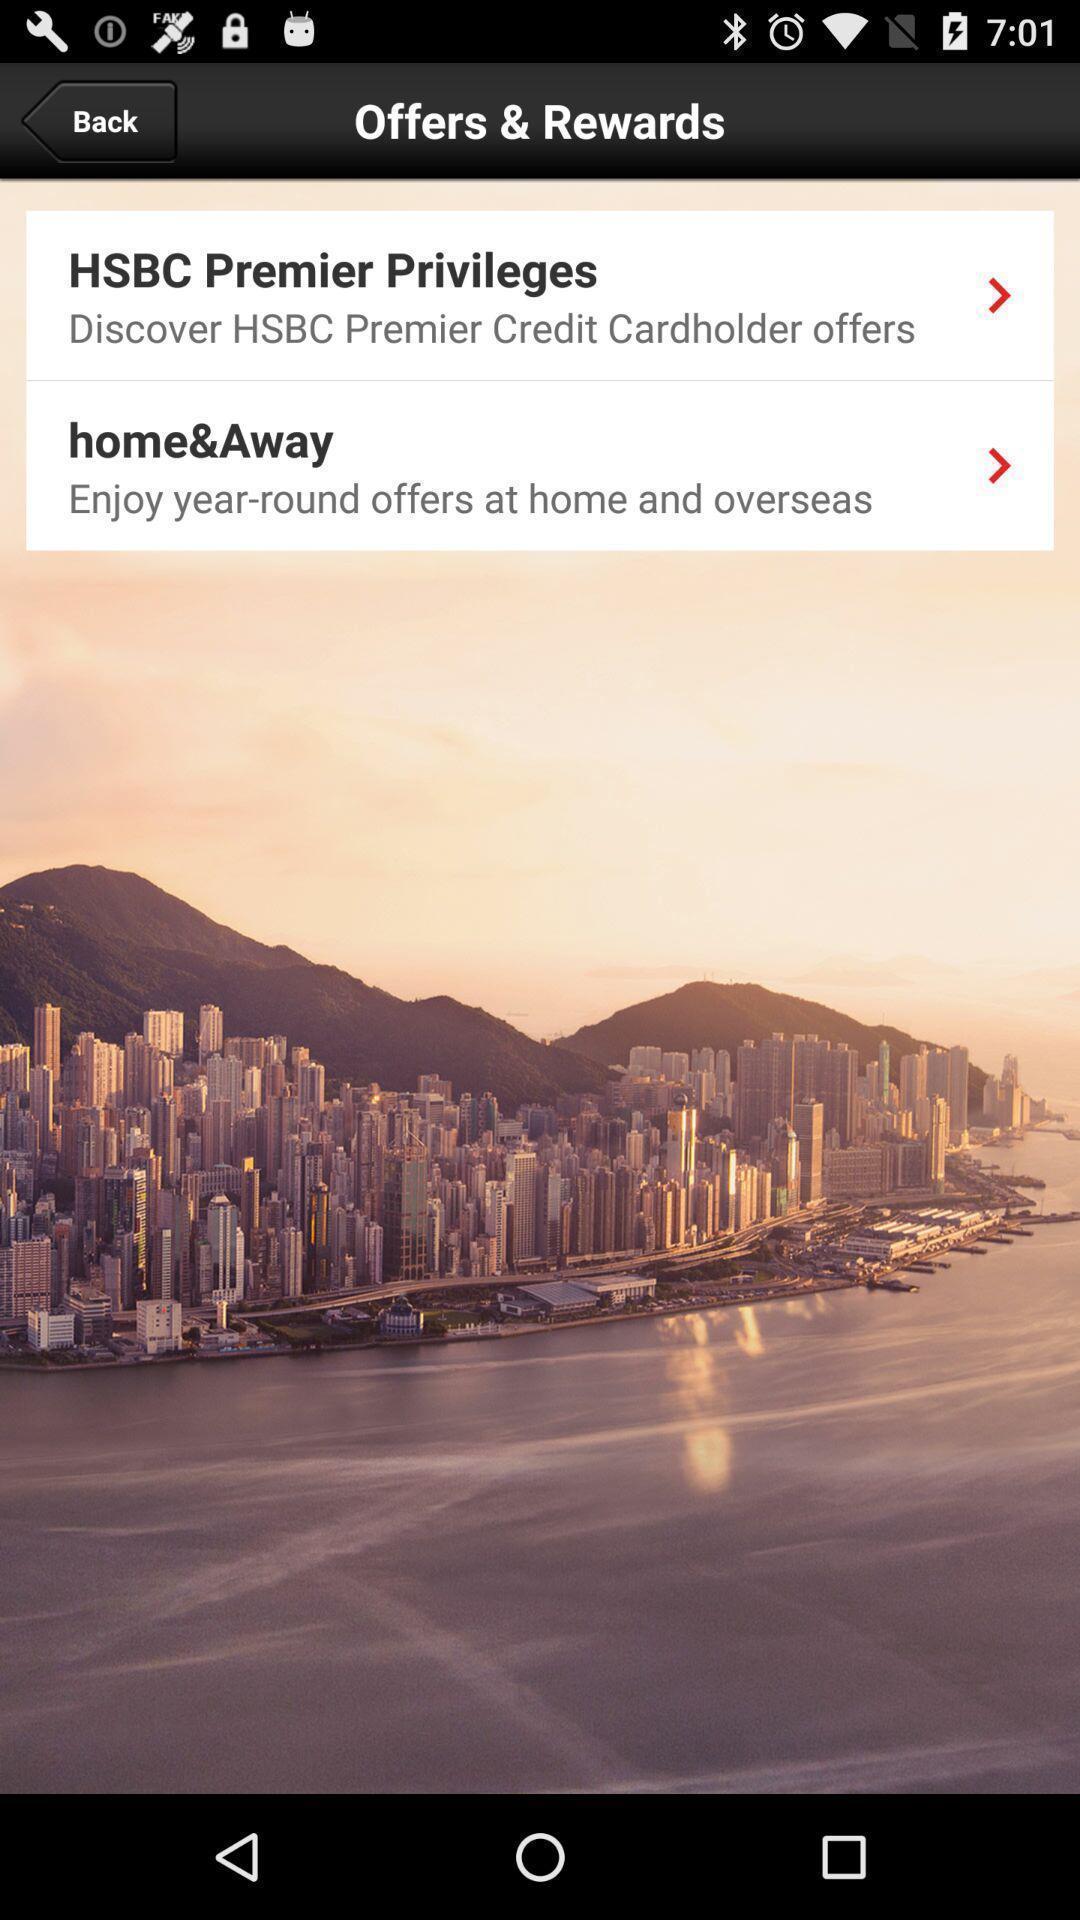What is the overall content of this screenshot? Screen shows rewards list in financial app. 